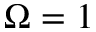Convert formula to latex. <formula><loc_0><loc_0><loc_500><loc_500>\Omega = 1</formula> 